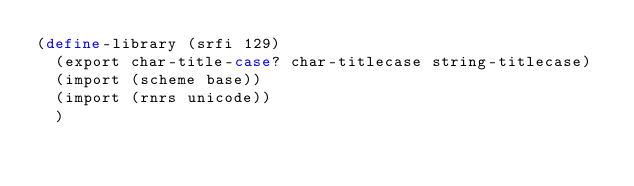<code> <loc_0><loc_0><loc_500><loc_500><_Scheme_>(define-library (srfi 129)
  (export char-title-case? char-titlecase string-titlecase)
  (import (scheme base))
  (import (rnrs unicode))
  )
</code> 